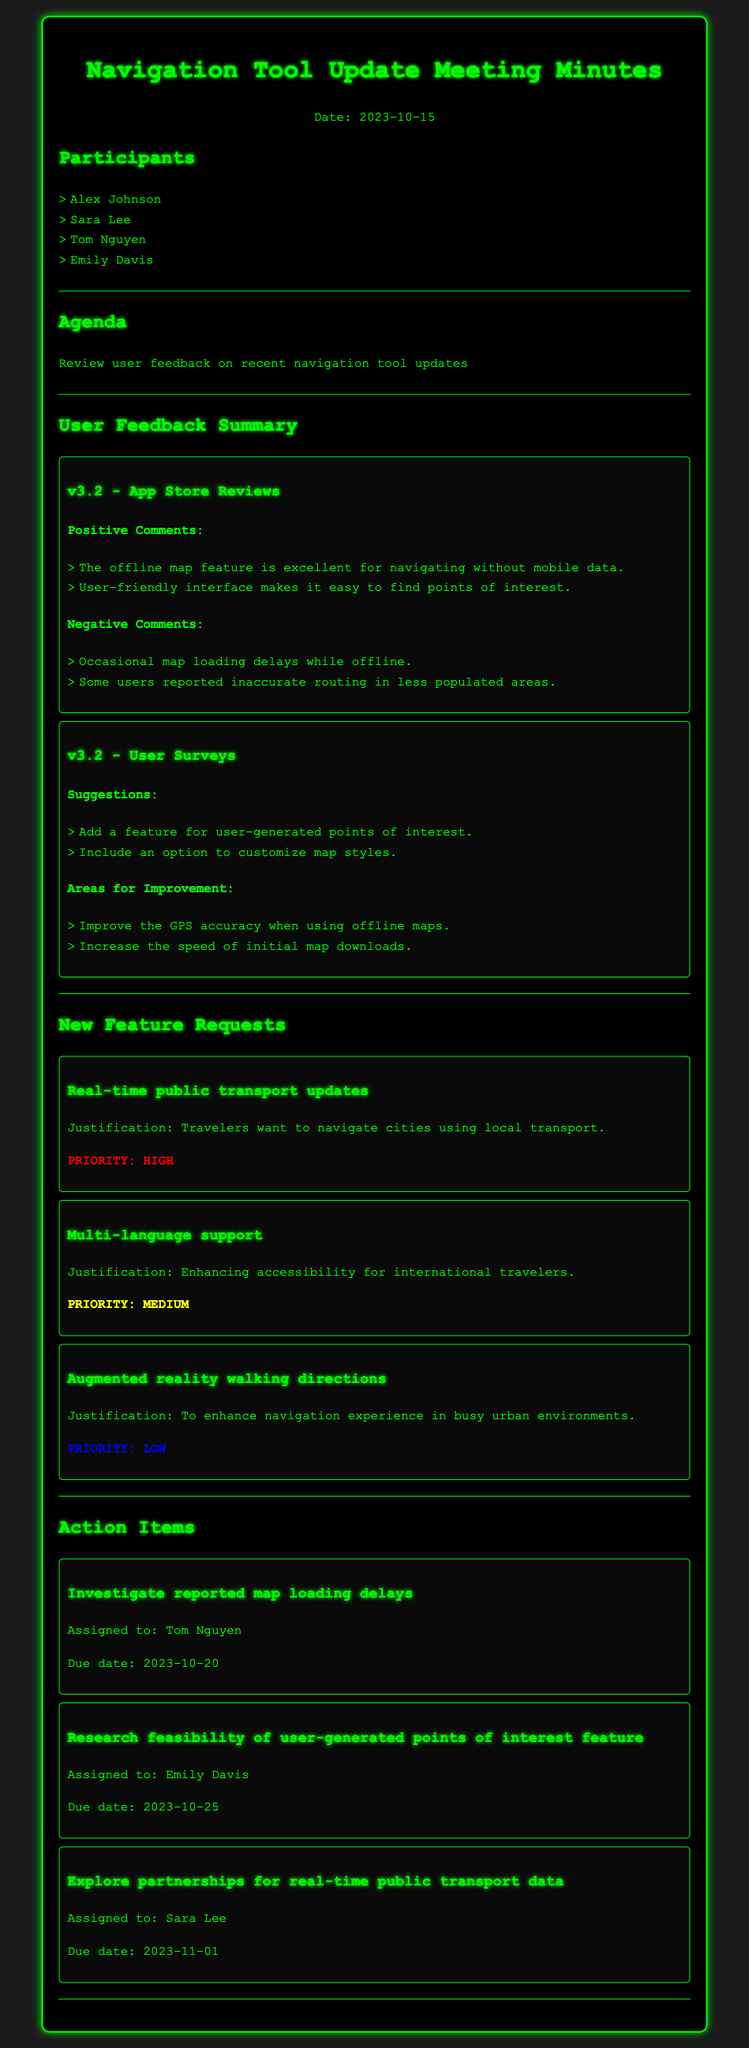What is the date of the meeting? The date of the meeting is mentioned in the header of the document as 2023-10-15.
Answer: 2023-10-15 Who is assigned to investigate reported map loading delays? The action item specifies that Tom Nguyen is assigned to investigate reported map loading delays.
Answer: Tom Nguyen What feature is requested with high priority? The document outlines three new feature requests, with "Real-time public transport updates" marked as high priority.
Answer: Real-time public transport updates How many positive comments were mentioned in the App Store reviews? In the user feedback summary for v3.2, there are two positive comments listed under App Store reviews.
Answer: 2 What is one area for improvement noted in the user surveys? The user surveys indicate that GPS accuracy when using offline maps is one area for improvement.
Answer: Improve the GPS accuracy when using offline maps Which participant is responsible for researching the feasibility of user-generated points of interest? The action item indicates that Emily Davis is responsible for researching the feasibility of user-generated points of interest.
Answer: Emily Davis What justification is provided for multi-language support? The justification given for multi-language support is enhancing accessibility for international travelers.
Answer: Enhancing accessibility for international travelers What was a common negative comment about the offline map feature? Users reported that there are occasional map loading delays while offline.
Answer: Occasional map loading delays while offline 